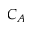<formula> <loc_0><loc_0><loc_500><loc_500>C _ { A }</formula> 